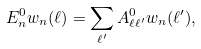<formula> <loc_0><loc_0><loc_500><loc_500>E ^ { 0 } _ { n } w _ { n } ( \ell ) = \sum _ { \ell ^ { \prime } } A ^ { 0 } _ { \ell \ell ^ { \prime } } w _ { n } ( \ell ^ { \prime } ) ,</formula> 